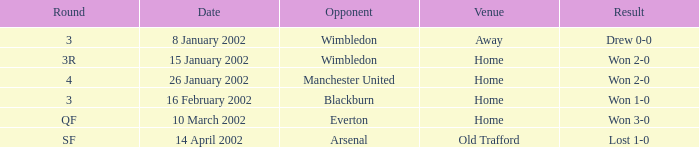What is the Round with a Opponent with blackburn? 3.0. Would you be able to parse every entry in this table? {'header': ['Round', 'Date', 'Opponent', 'Venue', 'Result'], 'rows': [['3', '8 January 2002', 'Wimbledon', 'Away', 'Drew 0-0'], ['3R', '15 January 2002', 'Wimbledon', 'Home', 'Won 2-0'], ['4', '26 January 2002', 'Manchester United', 'Home', 'Won 2-0'], ['3', '16 February 2002', 'Blackburn', 'Home', 'Won 1-0'], ['QF', '10 March 2002', 'Everton', 'Home', 'Won 3-0'], ['SF', '14 April 2002', 'Arsenal', 'Old Trafford', 'Lost 1-0']]} 